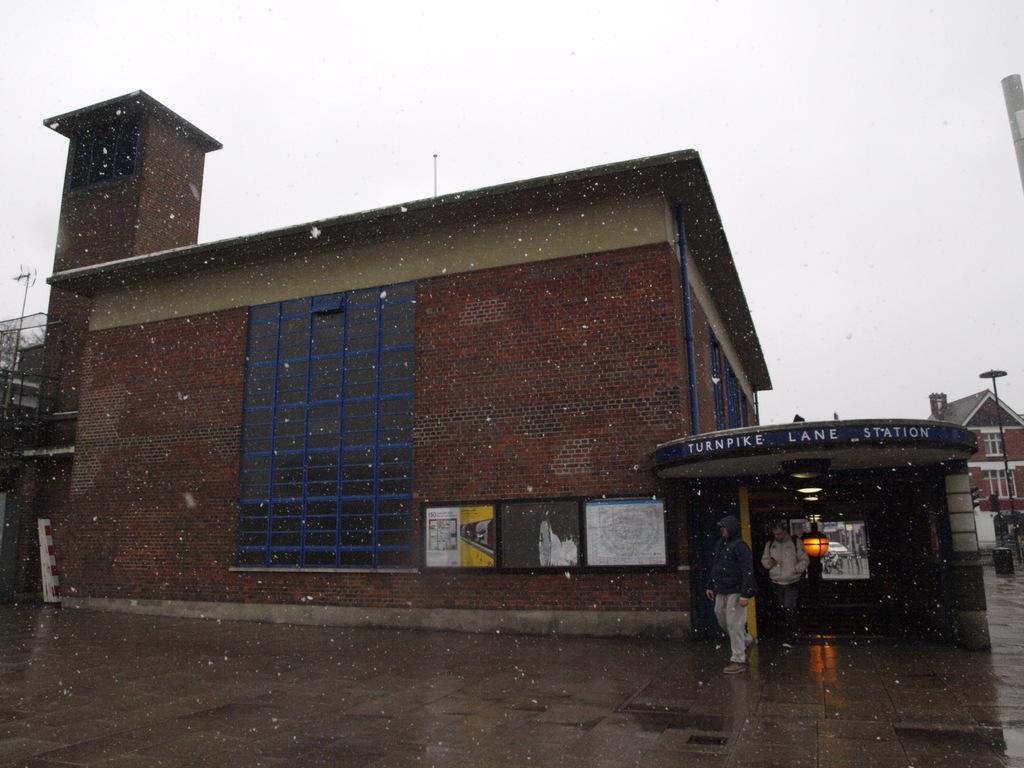How would you summarize this image in a sentence or two? This picture might be taken from outside of the building. In this image, on the right side, we can see two men are walking on the road, we can also see buildings, pole on the right side. In the middle of the image, we can see a building and a photo frame attached to a wall. On the left side, we can also see a building. At the top, we can see a sky. 